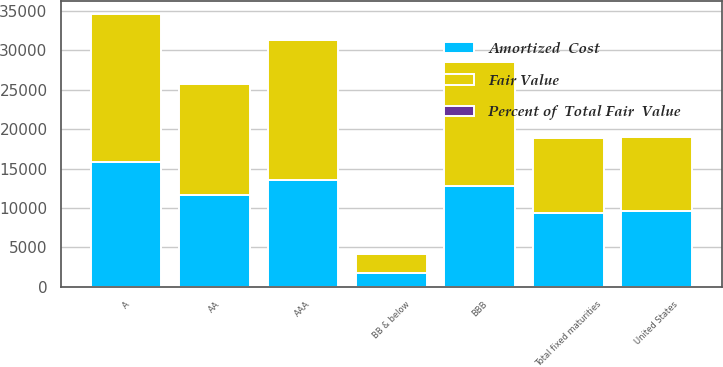Convert chart to OTSL. <chart><loc_0><loc_0><loc_500><loc_500><stacked_bar_chart><ecel><fcel>AAA<fcel>AA<fcel>A<fcel>BBB<fcel>United States<fcel>BB & below<fcel>Total fixed maturities<nl><fcel>Fair Value<fcel>17844<fcel>14093<fcel>18742<fcel>15749<fcel>9409<fcel>2401<fcel>9409<nl><fcel>Amortized  Cost<fcel>13489<fcel>11646<fcel>15831<fcel>12794<fcel>9568<fcel>1784<fcel>9409<nl><fcel>Percent of  Total Fair  Value<fcel>20.7<fcel>17.9<fcel>24.4<fcel>19.6<fcel>14.7<fcel>2.7<fcel>100<nl></chart> 